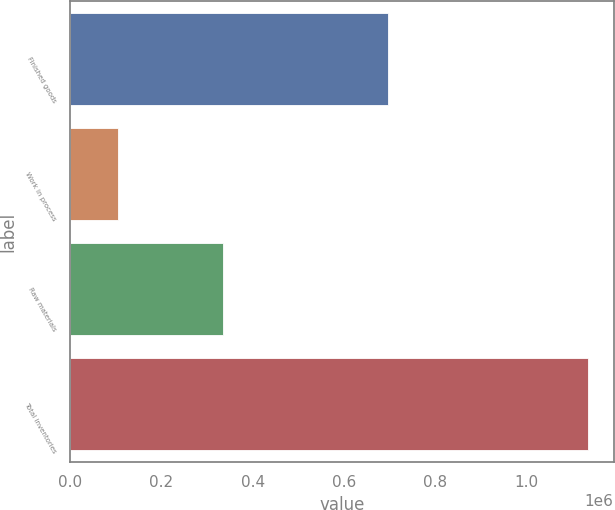Convert chart to OTSL. <chart><loc_0><loc_0><loc_500><loc_500><bar_chart><fcel>Finished goods<fcel>Work in process<fcel>Raw materials<fcel>Total inventories<nl><fcel>695606<fcel>103685<fcel>334445<fcel>1.13374e+06<nl></chart> 